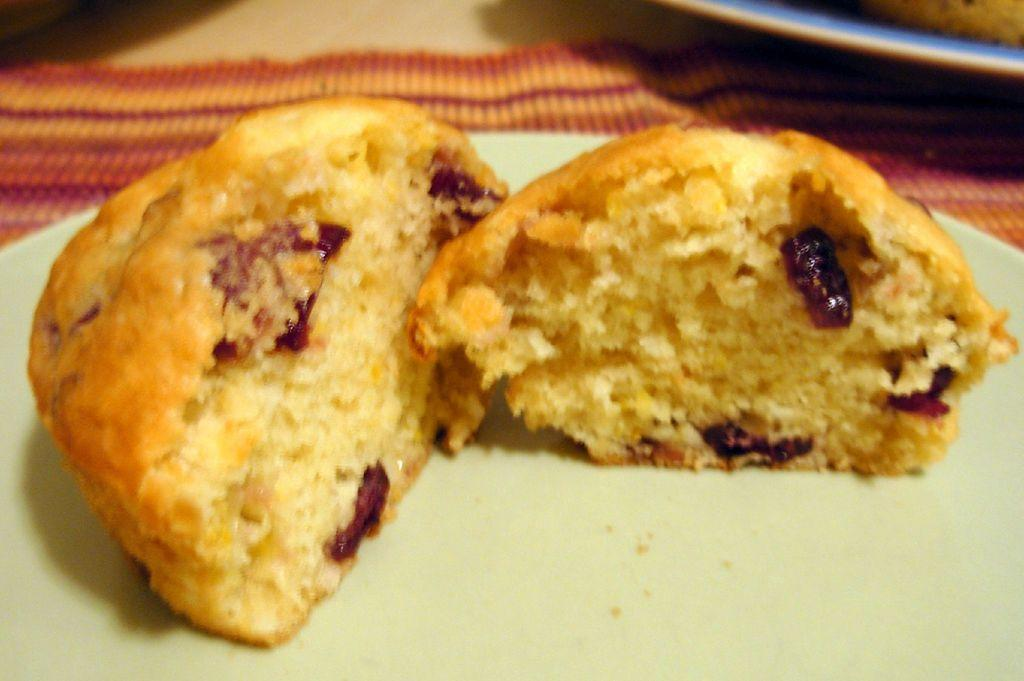What color is the plate in the image? The plate in the image is white colored. What is on the plate? There is a food item on the plate. Can you describe the appearance of the food item? The food item has a cream and brown color. What other objects can be seen in the image? There are other objects visible in the image. Is the food item in motion in the image? No, the food item is not in motion in the image; it is stationary on the plate. 